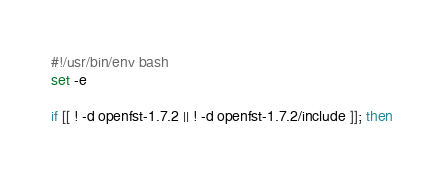<code> <loc_0><loc_0><loc_500><loc_500><_Bash_>#!/usr/bin/env bash
set -e

if [[ ! -d openfst-1.7.2 || ! -d openfst-1.7.2/include ]]; then</code> 